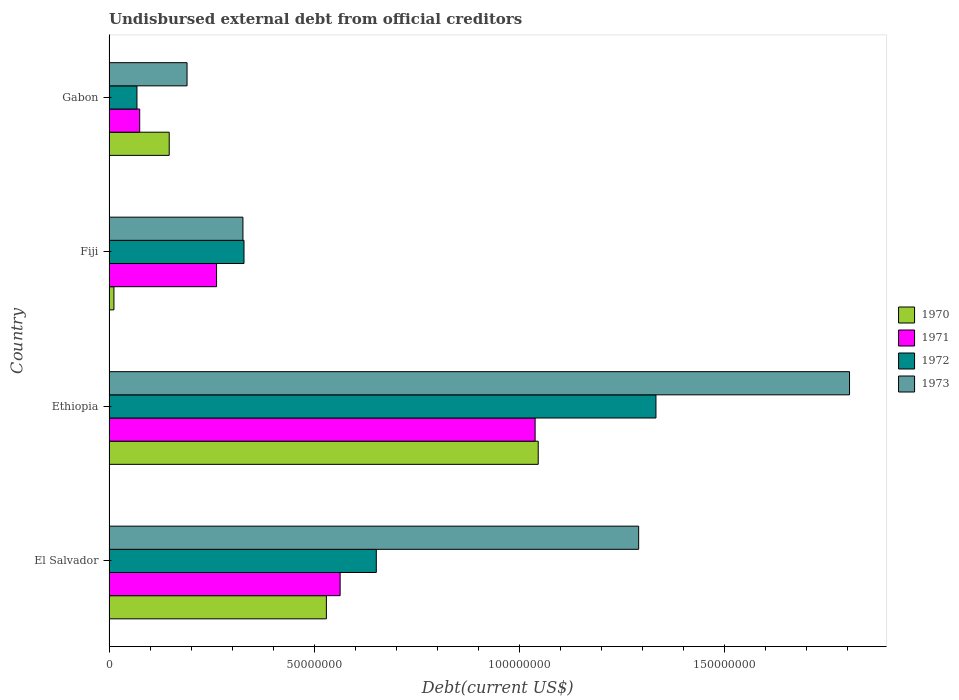How many different coloured bars are there?
Your answer should be very brief. 4. How many groups of bars are there?
Provide a short and direct response. 4. Are the number of bars per tick equal to the number of legend labels?
Offer a very short reply. Yes. Are the number of bars on each tick of the Y-axis equal?
Keep it short and to the point. Yes. How many bars are there on the 4th tick from the top?
Give a very brief answer. 4. How many bars are there on the 1st tick from the bottom?
Offer a terse response. 4. What is the label of the 2nd group of bars from the top?
Offer a very short reply. Fiji. What is the total debt in 1971 in Fiji?
Make the answer very short. 2.62e+07. Across all countries, what is the maximum total debt in 1971?
Provide a succinct answer. 1.04e+08. Across all countries, what is the minimum total debt in 1972?
Offer a terse response. 6.81e+06. In which country was the total debt in 1972 maximum?
Keep it short and to the point. Ethiopia. In which country was the total debt in 1970 minimum?
Make the answer very short. Fiji. What is the total total debt in 1972 in the graph?
Your response must be concise. 2.38e+08. What is the difference between the total debt in 1971 in Ethiopia and that in Gabon?
Offer a very short reply. 9.63e+07. What is the difference between the total debt in 1970 in Gabon and the total debt in 1973 in Fiji?
Keep it short and to the point. -1.80e+07. What is the average total debt in 1973 per country?
Give a very brief answer. 9.03e+07. What is the difference between the total debt in 1970 and total debt in 1971 in Gabon?
Your answer should be compact. 7.19e+06. What is the ratio of the total debt in 1970 in Fiji to that in Gabon?
Give a very brief answer. 0.08. Is the total debt in 1973 in Fiji less than that in Gabon?
Ensure brevity in your answer.  No. Is the difference between the total debt in 1970 in Fiji and Gabon greater than the difference between the total debt in 1971 in Fiji and Gabon?
Your answer should be compact. No. What is the difference between the highest and the second highest total debt in 1972?
Provide a short and direct response. 6.81e+07. What is the difference between the highest and the lowest total debt in 1970?
Make the answer very short. 1.03e+08. In how many countries, is the total debt in 1972 greater than the average total debt in 1972 taken over all countries?
Your answer should be compact. 2. Is it the case that in every country, the sum of the total debt in 1972 and total debt in 1971 is greater than the sum of total debt in 1973 and total debt in 1970?
Provide a short and direct response. No. What does the 3rd bar from the top in Gabon represents?
Provide a short and direct response. 1971. What does the 4th bar from the bottom in Gabon represents?
Offer a very short reply. 1973. How many bars are there?
Ensure brevity in your answer.  16. Are all the bars in the graph horizontal?
Your response must be concise. Yes. How many countries are there in the graph?
Give a very brief answer. 4. Does the graph contain grids?
Keep it short and to the point. No. What is the title of the graph?
Ensure brevity in your answer.  Undisbursed external debt from official creditors. What is the label or title of the X-axis?
Offer a terse response. Debt(current US$). What is the label or title of the Y-axis?
Offer a very short reply. Country. What is the Debt(current US$) of 1970 in El Salvador?
Keep it short and to the point. 5.30e+07. What is the Debt(current US$) of 1971 in El Salvador?
Make the answer very short. 5.63e+07. What is the Debt(current US$) of 1972 in El Salvador?
Give a very brief answer. 6.51e+07. What is the Debt(current US$) of 1973 in El Salvador?
Your answer should be compact. 1.29e+08. What is the Debt(current US$) in 1970 in Ethiopia?
Offer a terse response. 1.05e+08. What is the Debt(current US$) of 1971 in Ethiopia?
Ensure brevity in your answer.  1.04e+08. What is the Debt(current US$) of 1972 in Ethiopia?
Keep it short and to the point. 1.33e+08. What is the Debt(current US$) of 1973 in Ethiopia?
Offer a terse response. 1.80e+08. What is the Debt(current US$) in 1970 in Fiji?
Provide a short and direct response. 1.20e+06. What is the Debt(current US$) of 1971 in Fiji?
Your answer should be compact. 2.62e+07. What is the Debt(current US$) in 1972 in Fiji?
Your answer should be compact. 3.29e+07. What is the Debt(current US$) in 1973 in Fiji?
Offer a terse response. 3.26e+07. What is the Debt(current US$) of 1970 in Gabon?
Ensure brevity in your answer.  1.47e+07. What is the Debt(current US$) in 1971 in Gabon?
Ensure brevity in your answer.  7.48e+06. What is the Debt(current US$) of 1972 in Gabon?
Keep it short and to the point. 6.81e+06. What is the Debt(current US$) of 1973 in Gabon?
Your answer should be very brief. 1.90e+07. Across all countries, what is the maximum Debt(current US$) in 1970?
Provide a succinct answer. 1.05e+08. Across all countries, what is the maximum Debt(current US$) in 1971?
Provide a short and direct response. 1.04e+08. Across all countries, what is the maximum Debt(current US$) of 1972?
Keep it short and to the point. 1.33e+08. Across all countries, what is the maximum Debt(current US$) in 1973?
Offer a terse response. 1.80e+08. Across all countries, what is the minimum Debt(current US$) in 1970?
Ensure brevity in your answer.  1.20e+06. Across all countries, what is the minimum Debt(current US$) of 1971?
Your answer should be compact. 7.48e+06. Across all countries, what is the minimum Debt(current US$) in 1972?
Offer a terse response. 6.81e+06. Across all countries, what is the minimum Debt(current US$) in 1973?
Make the answer very short. 1.90e+07. What is the total Debt(current US$) of 1970 in the graph?
Provide a short and direct response. 1.73e+08. What is the total Debt(current US$) of 1971 in the graph?
Your response must be concise. 1.94e+08. What is the total Debt(current US$) of 1972 in the graph?
Offer a terse response. 2.38e+08. What is the total Debt(current US$) in 1973 in the graph?
Provide a succinct answer. 3.61e+08. What is the difference between the Debt(current US$) of 1970 in El Salvador and that in Ethiopia?
Make the answer very short. -5.16e+07. What is the difference between the Debt(current US$) in 1971 in El Salvador and that in Ethiopia?
Your response must be concise. -4.75e+07. What is the difference between the Debt(current US$) of 1972 in El Salvador and that in Ethiopia?
Offer a terse response. -6.81e+07. What is the difference between the Debt(current US$) of 1973 in El Salvador and that in Ethiopia?
Keep it short and to the point. -5.14e+07. What is the difference between the Debt(current US$) of 1970 in El Salvador and that in Fiji?
Ensure brevity in your answer.  5.18e+07. What is the difference between the Debt(current US$) of 1971 in El Salvador and that in Fiji?
Offer a very short reply. 3.01e+07. What is the difference between the Debt(current US$) of 1972 in El Salvador and that in Fiji?
Provide a succinct answer. 3.22e+07. What is the difference between the Debt(current US$) of 1973 in El Salvador and that in Fiji?
Ensure brevity in your answer.  9.64e+07. What is the difference between the Debt(current US$) of 1970 in El Salvador and that in Gabon?
Make the answer very short. 3.83e+07. What is the difference between the Debt(current US$) in 1971 in El Salvador and that in Gabon?
Ensure brevity in your answer.  4.88e+07. What is the difference between the Debt(current US$) of 1972 in El Salvador and that in Gabon?
Keep it short and to the point. 5.83e+07. What is the difference between the Debt(current US$) of 1973 in El Salvador and that in Gabon?
Offer a terse response. 1.10e+08. What is the difference between the Debt(current US$) in 1970 in Ethiopia and that in Fiji?
Your answer should be compact. 1.03e+08. What is the difference between the Debt(current US$) in 1971 in Ethiopia and that in Fiji?
Provide a short and direct response. 7.76e+07. What is the difference between the Debt(current US$) of 1972 in Ethiopia and that in Fiji?
Keep it short and to the point. 1.00e+08. What is the difference between the Debt(current US$) in 1973 in Ethiopia and that in Fiji?
Ensure brevity in your answer.  1.48e+08. What is the difference between the Debt(current US$) in 1970 in Ethiopia and that in Gabon?
Your answer should be compact. 8.99e+07. What is the difference between the Debt(current US$) in 1971 in Ethiopia and that in Gabon?
Offer a very short reply. 9.63e+07. What is the difference between the Debt(current US$) in 1972 in Ethiopia and that in Gabon?
Keep it short and to the point. 1.26e+08. What is the difference between the Debt(current US$) in 1973 in Ethiopia and that in Gabon?
Keep it short and to the point. 1.61e+08. What is the difference between the Debt(current US$) in 1970 in Fiji and that in Gabon?
Provide a short and direct response. -1.35e+07. What is the difference between the Debt(current US$) of 1971 in Fiji and that in Gabon?
Your answer should be compact. 1.87e+07. What is the difference between the Debt(current US$) in 1972 in Fiji and that in Gabon?
Ensure brevity in your answer.  2.61e+07. What is the difference between the Debt(current US$) in 1973 in Fiji and that in Gabon?
Offer a very short reply. 1.36e+07. What is the difference between the Debt(current US$) of 1970 in El Salvador and the Debt(current US$) of 1971 in Ethiopia?
Provide a short and direct response. -5.09e+07. What is the difference between the Debt(current US$) of 1970 in El Salvador and the Debt(current US$) of 1972 in Ethiopia?
Your answer should be compact. -8.03e+07. What is the difference between the Debt(current US$) in 1970 in El Salvador and the Debt(current US$) in 1973 in Ethiopia?
Your answer should be very brief. -1.27e+08. What is the difference between the Debt(current US$) of 1971 in El Salvador and the Debt(current US$) of 1972 in Ethiopia?
Your answer should be compact. -7.70e+07. What is the difference between the Debt(current US$) in 1971 in El Salvador and the Debt(current US$) in 1973 in Ethiopia?
Provide a short and direct response. -1.24e+08. What is the difference between the Debt(current US$) in 1972 in El Salvador and the Debt(current US$) in 1973 in Ethiopia?
Your response must be concise. -1.15e+08. What is the difference between the Debt(current US$) in 1970 in El Salvador and the Debt(current US$) in 1971 in Fiji?
Your response must be concise. 2.68e+07. What is the difference between the Debt(current US$) of 1970 in El Salvador and the Debt(current US$) of 1972 in Fiji?
Give a very brief answer. 2.01e+07. What is the difference between the Debt(current US$) in 1970 in El Salvador and the Debt(current US$) in 1973 in Fiji?
Provide a succinct answer. 2.03e+07. What is the difference between the Debt(current US$) of 1971 in El Salvador and the Debt(current US$) of 1972 in Fiji?
Provide a succinct answer. 2.34e+07. What is the difference between the Debt(current US$) in 1971 in El Salvador and the Debt(current US$) in 1973 in Fiji?
Your response must be concise. 2.37e+07. What is the difference between the Debt(current US$) of 1972 in El Salvador and the Debt(current US$) of 1973 in Fiji?
Keep it short and to the point. 3.25e+07. What is the difference between the Debt(current US$) of 1970 in El Salvador and the Debt(current US$) of 1971 in Gabon?
Make the answer very short. 4.55e+07. What is the difference between the Debt(current US$) in 1970 in El Salvador and the Debt(current US$) in 1972 in Gabon?
Offer a very short reply. 4.62e+07. What is the difference between the Debt(current US$) of 1970 in El Salvador and the Debt(current US$) of 1973 in Gabon?
Provide a succinct answer. 3.40e+07. What is the difference between the Debt(current US$) in 1971 in El Salvador and the Debt(current US$) in 1972 in Gabon?
Provide a succinct answer. 4.95e+07. What is the difference between the Debt(current US$) of 1971 in El Salvador and the Debt(current US$) of 1973 in Gabon?
Provide a short and direct response. 3.73e+07. What is the difference between the Debt(current US$) in 1972 in El Salvador and the Debt(current US$) in 1973 in Gabon?
Your answer should be compact. 4.61e+07. What is the difference between the Debt(current US$) of 1970 in Ethiopia and the Debt(current US$) of 1971 in Fiji?
Your answer should be very brief. 7.84e+07. What is the difference between the Debt(current US$) in 1970 in Ethiopia and the Debt(current US$) in 1972 in Fiji?
Give a very brief answer. 7.17e+07. What is the difference between the Debt(current US$) of 1970 in Ethiopia and the Debt(current US$) of 1973 in Fiji?
Provide a succinct answer. 7.19e+07. What is the difference between the Debt(current US$) in 1971 in Ethiopia and the Debt(current US$) in 1972 in Fiji?
Keep it short and to the point. 7.09e+07. What is the difference between the Debt(current US$) in 1971 in Ethiopia and the Debt(current US$) in 1973 in Fiji?
Your response must be concise. 7.12e+07. What is the difference between the Debt(current US$) in 1972 in Ethiopia and the Debt(current US$) in 1973 in Fiji?
Your response must be concise. 1.01e+08. What is the difference between the Debt(current US$) in 1970 in Ethiopia and the Debt(current US$) in 1971 in Gabon?
Provide a succinct answer. 9.71e+07. What is the difference between the Debt(current US$) of 1970 in Ethiopia and the Debt(current US$) of 1972 in Gabon?
Offer a very short reply. 9.78e+07. What is the difference between the Debt(current US$) in 1970 in Ethiopia and the Debt(current US$) in 1973 in Gabon?
Your answer should be compact. 8.56e+07. What is the difference between the Debt(current US$) in 1971 in Ethiopia and the Debt(current US$) in 1972 in Gabon?
Keep it short and to the point. 9.70e+07. What is the difference between the Debt(current US$) in 1971 in Ethiopia and the Debt(current US$) in 1973 in Gabon?
Make the answer very short. 8.48e+07. What is the difference between the Debt(current US$) in 1972 in Ethiopia and the Debt(current US$) in 1973 in Gabon?
Provide a succinct answer. 1.14e+08. What is the difference between the Debt(current US$) in 1970 in Fiji and the Debt(current US$) in 1971 in Gabon?
Your answer should be very brief. -6.28e+06. What is the difference between the Debt(current US$) of 1970 in Fiji and the Debt(current US$) of 1972 in Gabon?
Provide a short and direct response. -5.61e+06. What is the difference between the Debt(current US$) in 1970 in Fiji and the Debt(current US$) in 1973 in Gabon?
Offer a very short reply. -1.78e+07. What is the difference between the Debt(current US$) in 1971 in Fiji and the Debt(current US$) in 1972 in Gabon?
Offer a terse response. 1.94e+07. What is the difference between the Debt(current US$) in 1971 in Fiji and the Debt(current US$) in 1973 in Gabon?
Your response must be concise. 7.19e+06. What is the difference between the Debt(current US$) of 1972 in Fiji and the Debt(current US$) of 1973 in Gabon?
Keep it short and to the point. 1.39e+07. What is the average Debt(current US$) of 1970 per country?
Your answer should be compact. 4.34e+07. What is the average Debt(current US$) of 1971 per country?
Keep it short and to the point. 4.85e+07. What is the average Debt(current US$) of 1972 per country?
Provide a short and direct response. 5.95e+07. What is the average Debt(current US$) in 1973 per country?
Your response must be concise. 9.03e+07. What is the difference between the Debt(current US$) in 1970 and Debt(current US$) in 1971 in El Salvador?
Your answer should be very brief. -3.35e+06. What is the difference between the Debt(current US$) of 1970 and Debt(current US$) of 1972 in El Salvador?
Make the answer very short. -1.22e+07. What is the difference between the Debt(current US$) in 1970 and Debt(current US$) in 1973 in El Salvador?
Your answer should be very brief. -7.61e+07. What is the difference between the Debt(current US$) of 1971 and Debt(current US$) of 1972 in El Salvador?
Provide a short and direct response. -8.81e+06. What is the difference between the Debt(current US$) in 1971 and Debt(current US$) in 1973 in El Salvador?
Make the answer very short. -7.27e+07. What is the difference between the Debt(current US$) in 1972 and Debt(current US$) in 1973 in El Salvador?
Your answer should be very brief. -6.39e+07. What is the difference between the Debt(current US$) in 1970 and Debt(current US$) in 1971 in Ethiopia?
Give a very brief answer. 7.54e+05. What is the difference between the Debt(current US$) in 1970 and Debt(current US$) in 1972 in Ethiopia?
Offer a very short reply. -2.87e+07. What is the difference between the Debt(current US$) in 1970 and Debt(current US$) in 1973 in Ethiopia?
Your answer should be very brief. -7.59e+07. What is the difference between the Debt(current US$) of 1971 and Debt(current US$) of 1972 in Ethiopia?
Offer a terse response. -2.94e+07. What is the difference between the Debt(current US$) of 1971 and Debt(current US$) of 1973 in Ethiopia?
Provide a succinct answer. -7.66e+07. What is the difference between the Debt(current US$) of 1972 and Debt(current US$) of 1973 in Ethiopia?
Your answer should be compact. -4.72e+07. What is the difference between the Debt(current US$) in 1970 and Debt(current US$) in 1971 in Fiji?
Provide a short and direct response. -2.50e+07. What is the difference between the Debt(current US$) of 1970 and Debt(current US$) of 1972 in Fiji?
Keep it short and to the point. -3.17e+07. What is the difference between the Debt(current US$) of 1970 and Debt(current US$) of 1973 in Fiji?
Make the answer very short. -3.14e+07. What is the difference between the Debt(current US$) in 1971 and Debt(current US$) in 1972 in Fiji?
Your answer should be compact. -6.68e+06. What is the difference between the Debt(current US$) of 1971 and Debt(current US$) of 1973 in Fiji?
Offer a terse response. -6.42e+06. What is the difference between the Debt(current US$) of 1972 and Debt(current US$) of 1973 in Fiji?
Ensure brevity in your answer.  2.61e+05. What is the difference between the Debt(current US$) of 1970 and Debt(current US$) of 1971 in Gabon?
Your answer should be very brief. 7.19e+06. What is the difference between the Debt(current US$) of 1970 and Debt(current US$) of 1972 in Gabon?
Your answer should be compact. 7.86e+06. What is the difference between the Debt(current US$) in 1970 and Debt(current US$) in 1973 in Gabon?
Your answer should be very brief. -4.34e+06. What is the difference between the Debt(current US$) in 1971 and Debt(current US$) in 1972 in Gabon?
Make the answer very short. 6.70e+05. What is the difference between the Debt(current US$) of 1971 and Debt(current US$) of 1973 in Gabon?
Give a very brief answer. -1.15e+07. What is the difference between the Debt(current US$) of 1972 and Debt(current US$) of 1973 in Gabon?
Provide a succinct answer. -1.22e+07. What is the ratio of the Debt(current US$) of 1970 in El Salvador to that in Ethiopia?
Offer a very short reply. 0.51. What is the ratio of the Debt(current US$) in 1971 in El Salvador to that in Ethiopia?
Your response must be concise. 0.54. What is the ratio of the Debt(current US$) in 1972 in El Salvador to that in Ethiopia?
Your response must be concise. 0.49. What is the ratio of the Debt(current US$) of 1973 in El Salvador to that in Ethiopia?
Keep it short and to the point. 0.72. What is the ratio of the Debt(current US$) in 1970 in El Salvador to that in Fiji?
Your response must be concise. 44.14. What is the ratio of the Debt(current US$) in 1971 in El Salvador to that in Fiji?
Your response must be concise. 2.15. What is the ratio of the Debt(current US$) of 1972 in El Salvador to that in Fiji?
Provide a succinct answer. 1.98. What is the ratio of the Debt(current US$) of 1973 in El Salvador to that in Fiji?
Your response must be concise. 3.95. What is the ratio of the Debt(current US$) of 1970 in El Salvador to that in Gabon?
Your response must be concise. 3.61. What is the ratio of the Debt(current US$) of 1971 in El Salvador to that in Gabon?
Your response must be concise. 7.53. What is the ratio of the Debt(current US$) in 1972 in El Salvador to that in Gabon?
Offer a very short reply. 9.57. What is the ratio of the Debt(current US$) in 1973 in El Salvador to that in Gabon?
Provide a succinct answer. 6.79. What is the ratio of the Debt(current US$) in 1970 in Ethiopia to that in Fiji?
Ensure brevity in your answer.  87.15. What is the ratio of the Debt(current US$) of 1971 in Ethiopia to that in Fiji?
Give a very brief answer. 3.96. What is the ratio of the Debt(current US$) of 1972 in Ethiopia to that in Fiji?
Provide a short and direct response. 4.05. What is the ratio of the Debt(current US$) in 1973 in Ethiopia to that in Fiji?
Provide a succinct answer. 5.53. What is the ratio of the Debt(current US$) of 1970 in Ethiopia to that in Gabon?
Your answer should be very brief. 7.13. What is the ratio of the Debt(current US$) in 1971 in Ethiopia to that in Gabon?
Make the answer very short. 13.89. What is the ratio of the Debt(current US$) of 1972 in Ethiopia to that in Gabon?
Provide a short and direct response. 19.58. What is the ratio of the Debt(current US$) of 1973 in Ethiopia to that in Gabon?
Your answer should be compact. 9.49. What is the ratio of the Debt(current US$) of 1970 in Fiji to that in Gabon?
Offer a terse response. 0.08. What is the ratio of the Debt(current US$) of 1971 in Fiji to that in Gabon?
Ensure brevity in your answer.  3.5. What is the ratio of the Debt(current US$) of 1972 in Fiji to that in Gabon?
Your answer should be very brief. 4.83. What is the ratio of the Debt(current US$) of 1973 in Fiji to that in Gabon?
Your answer should be compact. 1.72. What is the difference between the highest and the second highest Debt(current US$) in 1970?
Provide a succinct answer. 5.16e+07. What is the difference between the highest and the second highest Debt(current US$) of 1971?
Provide a short and direct response. 4.75e+07. What is the difference between the highest and the second highest Debt(current US$) of 1972?
Offer a very short reply. 6.81e+07. What is the difference between the highest and the second highest Debt(current US$) of 1973?
Keep it short and to the point. 5.14e+07. What is the difference between the highest and the lowest Debt(current US$) of 1970?
Provide a short and direct response. 1.03e+08. What is the difference between the highest and the lowest Debt(current US$) in 1971?
Your answer should be compact. 9.63e+07. What is the difference between the highest and the lowest Debt(current US$) in 1972?
Ensure brevity in your answer.  1.26e+08. What is the difference between the highest and the lowest Debt(current US$) of 1973?
Make the answer very short. 1.61e+08. 